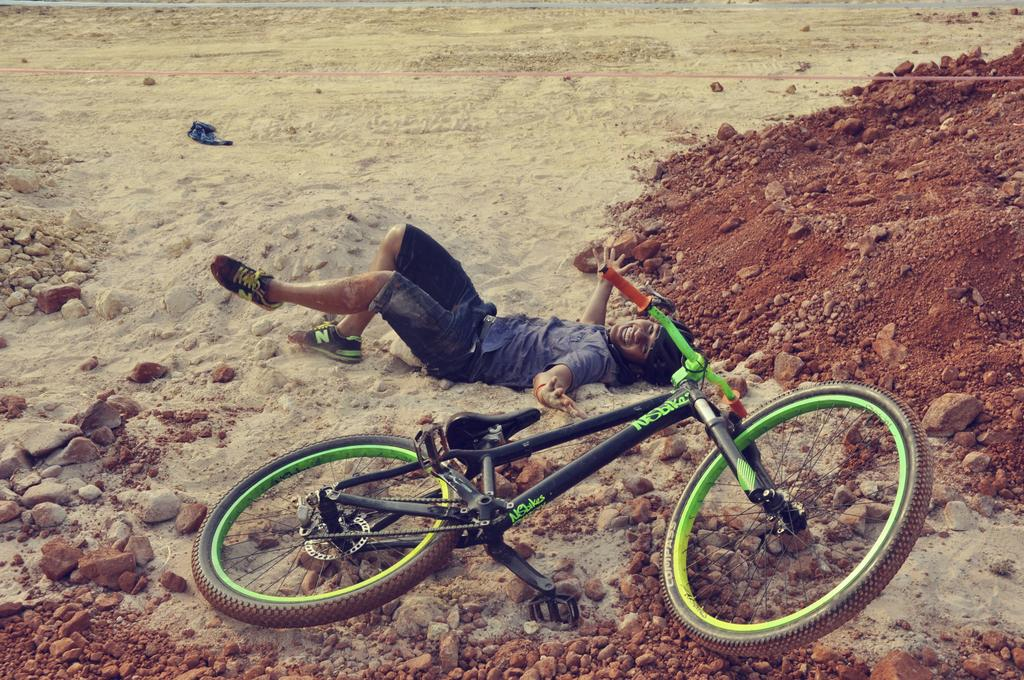What is the man in the image doing? The man is lying on the sand in the image. What type of surface is the man lying on? The man is lying on sand. What else can be seen in the image besides the man? There are stones and a bicycle visible in the image. How many cherries are on the bicycle in the image? There are no cherries present in the image. 